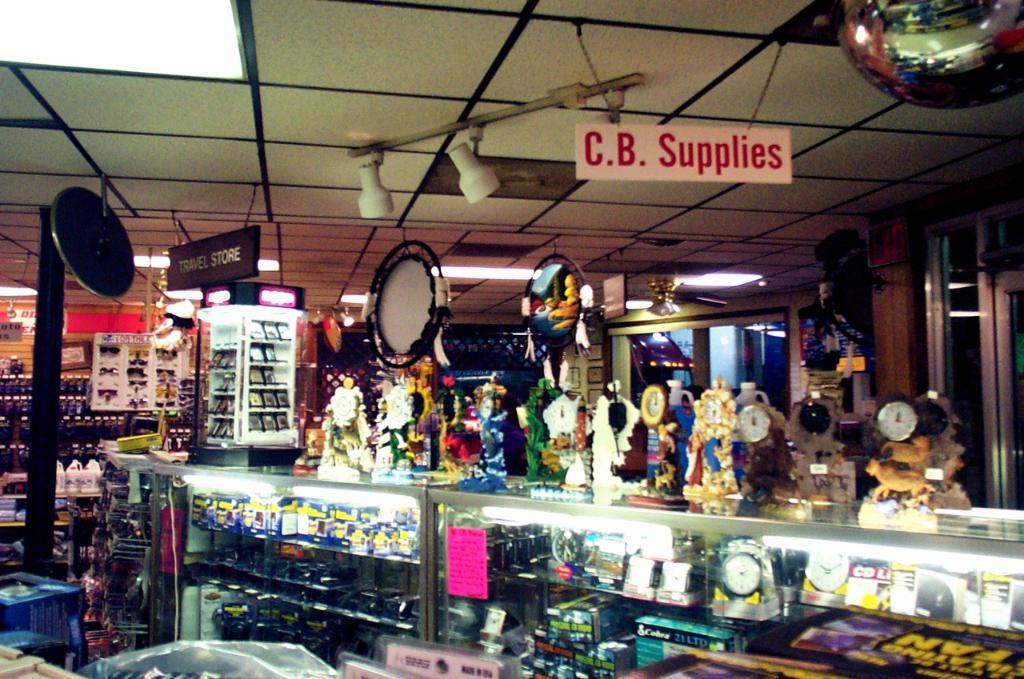<image>
Describe the image concisely. Store with a white sign that says "CB Supplies" in red letters. 